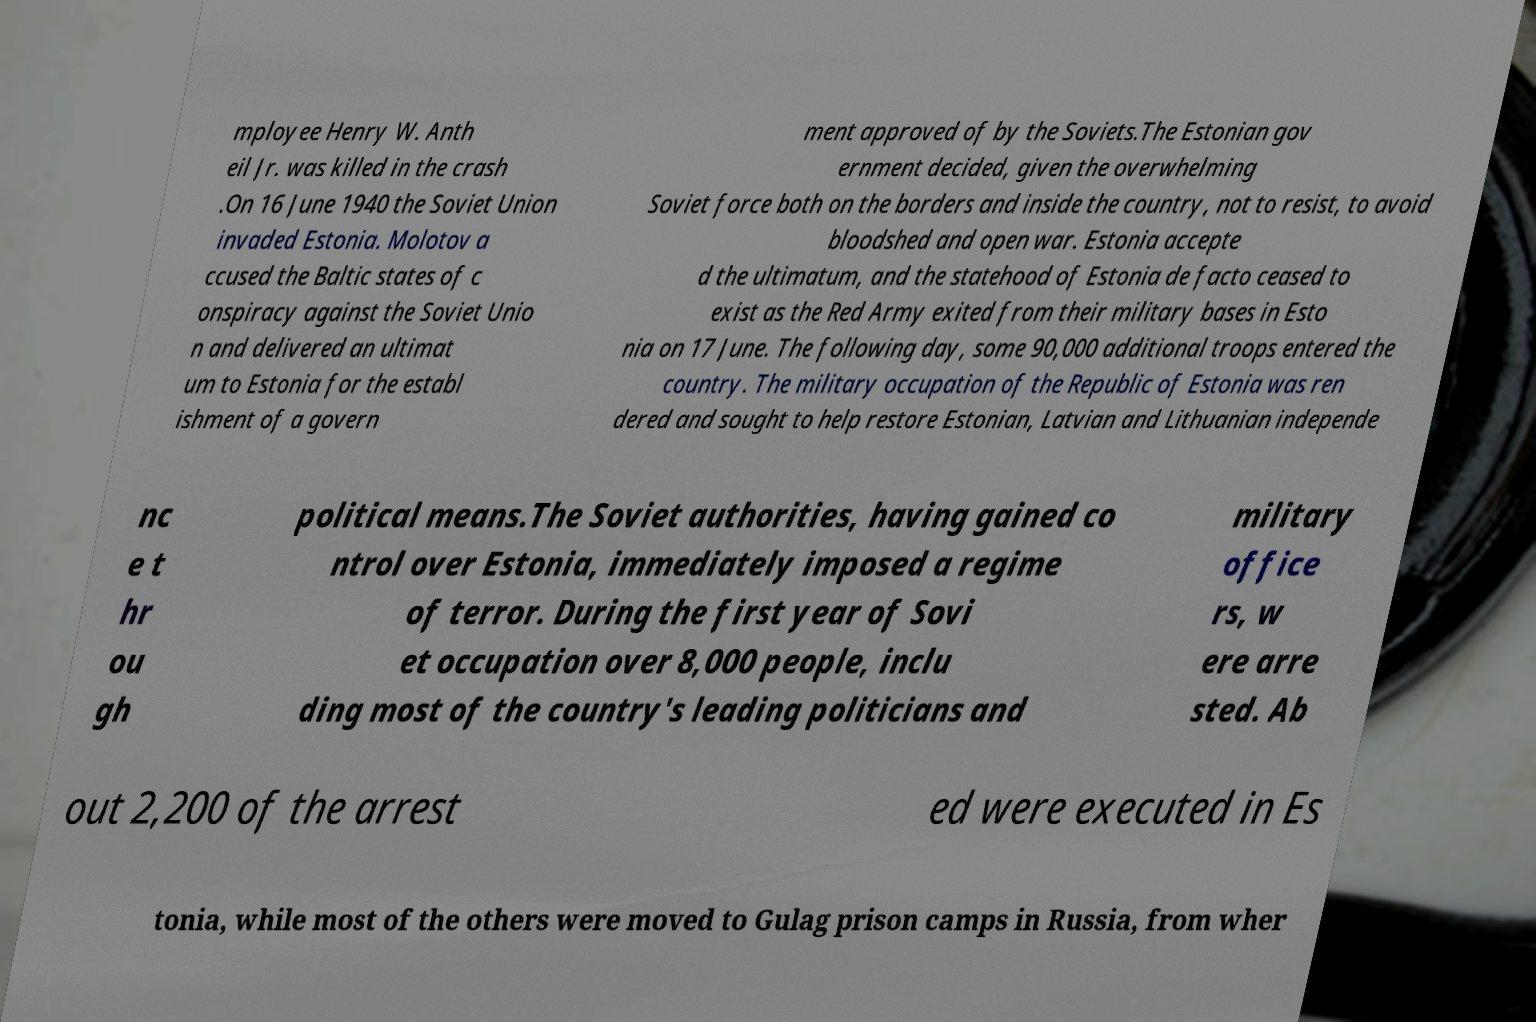Could you extract and type out the text from this image? mployee Henry W. Anth eil Jr. was killed in the crash .On 16 June 1940 the Soviet Union invaded Estonia. Molotov a ccused the Baltic states of c onspiracy against the Soviet Unio n and delivered an ultimat um to Estonia for the establ ishment of a govern ment approved of by the Soviets.The Estonian gov ernment decided, given the overwhelming Soviet force both on the borders and inside the country, not to resist, to avoid bloodshed and open war. Estonia accepte d the ultimatum, and the statehood of Estonia de facto ceased to exist as the Red Army exited from their military bases in Esto nia on 17 June. The following day, some 90,000 additional troops entered the country. The military occupation of the Republic of Estonia was ren dered and sought to help restore Estonian, Latvian and Lithuanian independe nc e t hr ou gh political means.The Soviet authorities, having gained co ntrol over Estonia, immediately imposed a regime of terror. During the first year of Sovi et occupation over 8,000 people, inclu ding most of the country's leading politicians and military office rs, w ere arre sted. Ab out 2,200 of the arrest ed were executed in Es tonia, while most of the others were moved to Gulag prison camps in Russia, from wher 